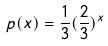Convert formula to latex. <formula><loc_0><loc_0><loc_500><loc_500>p ( x ) = \frac { 1 } { 3 } ( \frac { 2 } { 3 } ) ^ { x }</formula> 